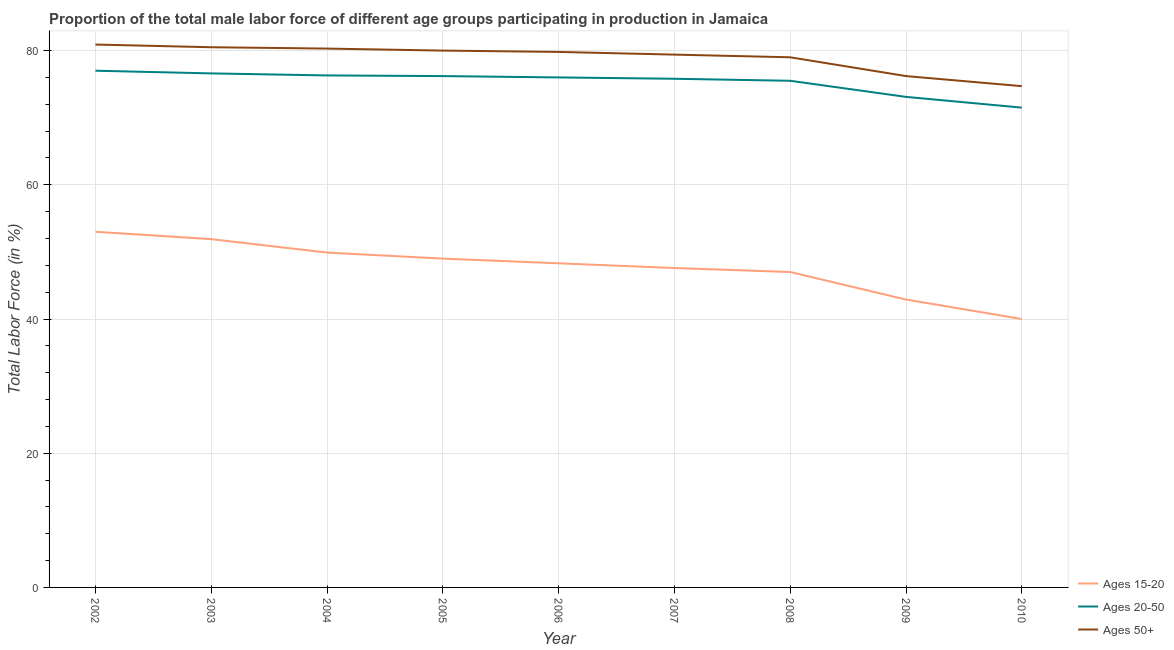How many different coloured lines are there?
Provide a short and direct response. 3. Is the number of lines equal to the number of legend labels?
Your answer should be compact. Yes. What is the percentage of male labor force within the age group 20-50 in 2010?
Your response must be concise. 71.5. Across all years, what is the maximum percentage of male labor force within the age group 20-50?
Provide a succinct answer. 77. What is the total percentage of male labor force within the age group 15-20 in the graph?
Your response must be concise. 429.6. What is the difference between the percentage of male labor force within the age group 15-20 in 2005 and that in 2008?
Offer a very short reply. 2. What is the difference between the percentage of male labor force within the age group 20-50 in 2008 and the percentage of male labor force above age 50 in 2009?
Provide a succinct answer. -0.7. What is the average percentage of male labor force above age 50 per year?
Your response must be concise. 78.98. In how many years, is the percentage of male labor force within the age group 15-20 greater than 36 %?
Provide a short and direct response. 9. What is the ratio of the percentage of male labor force within the age group 20-50 in 2008 to that in 2010?
Your answer should be compact. 1.06. Is the difference between the percentage of male labor force within the age group 15-20 in 2006 and 2007 greater than the difference between the percentage of male labor force above age 50 in 2006 and 2007?
Keep it short and to the point. Yes. What is the difference between the highest and the second highest percentage of male labor force above age 50?
Provide a succinct answer. 0.4. What is the difference between the highest and the lowest percentage of male labor force above age 50?
Offer a terse response. 6.2. Is the sum of the percentage of male labor force above age 50 in 2005 and 2009 greater than the maximum percentage of male labor force within the age group 15-20 across all years?
Offer a terse response. Yes. Is the percentage of male labor force above age 50 strictly less than the percentage of male labor force within the age group 15-20 over the years?
Offer a terse response. No. How many lines are there?
Keep it short and to the point. 3. What is the difference between two consecutive major ticks on the Y-axis?
Your answer should be compact. 20. Are the values on the major ticks of Y-axis written in scientific E-notation?
Your response must be concise. No. Does the graph contain grids?
Offer a very short reply. Yes. Where does the legend appear in the graph?
Offer a terse response. Bottom right. How many legend labels are there?
Your response must be concise. 3. What is the title of the graph?
Your response must be concise. Proportion of the total male labor force of different age groups participating in production in Jamaica. Does "Tertiary" appear as one of the legend labels in the graph?
Ensure brevity in your answer.  No. What is the label or title of the X-axis?
Give a very brief answer. Year. What is the Total Labor Force (in %) in Ages 15-20 in 2002?
Make the answer very short. 53. What is the Total Labor Force (in %) in Ages 50+ in 2002?
Your answer should be very brief. 80.9. What is the Total Labor Force (in %) in Ages 15-20 in 2003?
Provide a succinct answer. 51.9. What is the Total Labor Force (in %) of Ages 20-50 in 2003?
Your answer should be compact. 76.6. What is the Total Labor Force (in %) in Ages 50+ in 2003?
Your response must be concise. 80.5. What is the Total Labor Force (in %) of Ages 15-20 in 2004?
Your answer should be very brief. 49.9. What is the Total Labor Force (in %) of Ages 20-50 in 2004?
Offer a terse response. 76.3. What is the Total Labor Force (in %) in Ages 50+ in 2004?
Offer a terse response. 80.3. What is the Total Labor Force (in %) in Ages 15-20 in 2005?
Keep it short and to the point. 49. What is the Total Labor Force (in %) of Ages 20-50 in 2005?
Offer a terse response. 76.2. What is the Total Labor Force (in %) in Ages 50+ in 2005?
Your answer should be very brief. 80. What is the Total Labor Force (in %) in Ages 15-20 in 2006?
Ensure brevity in your answer.  48.3. What is the Total Labor Force (in %) of Ages 50+ in 2006?
Your response must be concise. 79.8. What is the Total Labor Force (in %) of Ages 15-20 in 2007?
Provide a succinct answer. 47.6. What is the Total Labor Force (in %) in Ages 20-50 in 2007?
Give a very brief answer. 75.8. What is the Total Labor Force (in %) in Ages 50+ in 2007?
Keep it short and to the point. 79.4. What is the Total Labor Force (in %) in Ages 20-50 in 2008?
Offer a terse response. 75.5. What is the Total Labor Force (in %) of Ages 50+ in 2008?
Your answer should be very brief. 79. What is the Total Labor Force (in %) in Ages 15-20 in 2009?
Offer a terse response. 42.9. What is the Total Labor Force (in %) of Ages 20-50 in 2009?
Give a very brief answer. 73.1. What is the Total Labor Force (in %) in Ages 50+ in 2009?
Offer a terse response. 76.2. What is the Total Labor Force (in %) in Ages 15-20 in 2010?
Your answer should be compact. 40. What is the Total Labor Force (in %) in Ages 20-50 in 2010?
Provide a succinct answer. 71.5. What is the Total Labor Force (in %) of Ages 50+ in 2010?
Give a very brief answer. 74.7. Across all years, what is the maximum Total Labor Force (in %) of Ages 15-20?
Offer a very short reply. 53. Across all years, what is the maximum Total Labor Force (in %) of Ages 20-50?
Your answer should be very brief. 77. Across all years, what is the maximum Total Labor Force (in %) of Ages 50+?
Ensure brevity in your answer.  80.9. Across all years, what is the minimum Total Labor Force (in %) of Ages 20-50?
Provide a succinct answer. 71.5. Across all years, what is the minimum Total Labor Force (in %) of Ages 50+?
Provide a succinct answer. 74.7. What is the total Total Labor Force (in %) of Ages 15-20 in the graph?
Your answer should be compact. 429.6. What is the total Total Labor Force (in %) in Ages 20-50 in the graph?
Your response must be concise. 678. What is the total Total Labor Force (in %) in Ages 50+ in the graph?
Keep it short and to the point. 710.8. What is the difference between the Total Labor Force (in %) in Ages 20-50 in 2002 and that in 2003?
Your response must be concise. 0.4. What is the difference between the Total Labor Force (in %) in Ages 50+ in 2002 and that in 2003?
Offer a terse response. 0.4. What is the difference between the Total Labor Force (in %) in Ages 15-20 in 2002 and that in 2004?
Give a very brief answer. 3.1. What is the difference between the Total Labor Force (in %) of Ages 50+ in 2002 and that in 2004?
Your answer should be compact. 0.6. What is the difference between the Total Labor Force (in %) of Ages 20-50 in 2002 and that in 2005?
Offer a terse response. 0.8. What is the difference between the Total Labor Force (in %) in Ages 50+ in 2002 and that in 2005?
Give a very brief answer. 0.9. What is the difference between the Total Labor Force (in %) of Ages 15-20 in 2002 and that in 2006?
Provide a short and direct response. 4.7. What is the difference between the Total Labor Force (in %) of Ages 50+ in 2002 and that in 2006?
Provide a short and direct response. 1.1. What is the difference between the Total Labor Force (in %) of Ages 15-20 in 2002 and that in 2007?
Your answer should be compact. 5.4. What is the difference between the Total Labor Force (in %) in Ages 20-50 in 2002 and that in 2007?
Give a very brief answer. 1.2. What is the difference between the Total Labor Force (in %) of Ages 50+ in 2002 and that in 2007?
Provide a short and direct response. 1.5. What is the difference between the Total Labor Force (in %) in Ages 15-20 in 2002 and that in 2008?
Provide a succinct answer. 6. What is the difference between the Total Labor Force (in %) in Ages 50+ in 2002 and that in 2008?
Provide a succinct answer. 1.9. What is the difference between the Total Labor Force (in %) of Ages 20-50 in 2002 and that in 2009?
Your answer should be compact. 3.9. What is the difference between the Total Labor Force (in %) of Ages 50+ in 2002 and that in 2009?
Make the answer very short. 4.7. What is the difference between the Total Labor Force (in %) in Ages 20-50 in 2002 and that in 2010?
Make the answer very short. 5.5. What is the difference between the Total Labor Force (in %) in Ages 20-50 in 2003 and that in 2004?
Your answer should be very brief. 0.3. What is the difference between the Total Labor Force (in %) of Ages 50+ in 2003 and that in 2004?
Provide a succinct answer. 0.2. What is the difference between the Total Labor Force (in %) of Ages 20-50 in 2003 and that in 2006?
Offer a very short reply. 0.6. What is the difference between the Total Labor Force (in %) of Ages 20-50 in 2003 and that in 2007?
Give a very brief answer. 0.8. What is the difference between the Total Labor Force (in %) of Ages 15-20 in 2003 and that in 2008?
Ensure brevity in your answer.  4.9. What is the difference between the Total Labor Force (in %) in Ages 20-50 in 2003 and that in 2008?
Ensure brevity in your answer.  1.1. What is the difference between the Total Labor Force (in %) of Ages 15-20 in 2003 and that in 2009?
Your answer should be very brief. 9. What is the difference between the Total Labor Force (in %) in Ages 20-50 in 2003 and that in 2009?
Your answer should be compact. 3.5. What is the difference between the Total Labor Force (in %) in Ages 50+ in 2003 and that in 2009?
Offer a terse response. 4.3. What is the difference between the Total Labor Force (in %) in Ages 15-20 in 2003 and that in 2010?
Your response must be concise. 11.9. What is the difference between the Total Labor Force (in %) of Ages 20-50 in 2003 and that in 2010?
Your answer should be very brief. 5.1. What is the difference between the Total Labor Force (in %) of Ages 15-20 in 2004 and that in 2005?
Give a very brief answer. 0.9. What is the difference between the Total Labor Force (in %) of Ages 20-50 in 2004 and that in 2005?
Give a very brief answer. 0.1. What is the difference between the Total Labor Force (in %) of Ages 50+ in 2004 and that in 2005?
Offer a very short reply. 0.3. What is the difference between the Total Labor Force (in %) in Ages 15-20 in 2004 and that in 2006?
Keep it short and to the point. 1.6. What is the difference between the Total Labor Force (in %) of Ages 50+ in 2004 and that in 2006?
Your response must be concise. 0.5. What is the difference between the Total Labor Force (in %) of Ages 15-20 in 2004 and that in 2007?
Give a very brief answer. 2.3. What is the difference between the Total Labor Force (in %) of Ages 50+ in 2004 and that in 2007?
Provide a succinct answer. 0.9. What is the difference between the Total Labor Force (in %) in Ages 50+ in 2004 and that in 2008?
Provide a short and direct response. 1.3. What is the difference between the Total Labor Force (in %) in Ages 20-50 in 2004 and that in 2009?
Offer a terse response. 3.2. What is the difference between the Total Labor Force (in %) in Ages 50+ in 2004 and that in 2009?
Your answer should be compact. 4.1. What is the difference between the Total Labor Force (in %) in Ages 15-20 in 2005 and that in 2006?
Offer a very short reply. 0.7. What is the difference between the Total Labor Force (in %) in Ages 20-50 in 2005 and that in 2006?
Keep it short and to the point. 0.2. What is the difference between the Total Labor Force (in %) in Ages 50+ in 2005 and that in 2006?
Your response must be concise. 0.2. What is the difference between the Total Labor Force (in %) of Ages 50+ in 2005 and that in 2007?
Give a very brief answer. 0.6. What is the difference between the Total Labor Force (in %) in Ages 15-20 in 2005 and that in 2008?
Give a very brief answer. 2. What is the difference between the Total Labor Force (in %) of Ages 20-50 in 2005 and that in 2008?
Your response must be concise. 0.7. What is the difference between the Total Labor Force (in %) of Ages 50+ in 2005 and that in 2008?
Provide a short and direct response. 1. What is the difference between the Total Labor Force (in %) of Ages 15-20 in 2005 and that in 2010?
Your response must be concise. 9. What is the difference between the Total Labor Force (in %) of Ages 15-20 in 2006 and that in 2007?
Provide a short and direct response. 0.7. What is the difference between the Total Labor Force (in %) in Ages 20-50 in 2006 and that in 2007?
Your answer should be very brief. 0.2. What is the difference between the Total Labor Force (in %) in Ages 15-20 in 2006 and that in 2008?
Your answer should be compact. 1.3. What is the difference between the Total Labor Force (in %) of Ages 20-50 in 2006 and that in 2008?
Provide a succinct answer. 0.5. What is the difference between the Total Labor Force (in %) in Ages 50+ in 2006 and that in 2008?
Provide a short and direct response. 0.8. What is the difference between the Total Labor Force (in %) of Ages 15-20 in 2006 and that in 2009?
Ensure brevity in your answer.  5.4. What is the difference between the Total Labor Force (in %) of Ages 50+ in 2006 and that in 2009?
Your answer should be very brief. 3.6. What is the difference between the Total Labor Force (in %) in Ages 20-50 in 2006 and that in 2010?
Make the answer very short. 4.5. What is the difference between the Total Labor Force (in %) in Ages 50+ in 2006 and that in 2010?
Make the answer very short. 5.1. What is the difference between the Total Labor Force (in %) of Ages 50+ in 2007 and that in 2008?
Make the answer very short. 0.4. What is the difference between the Total Labor Force (in %) in Ages 15-20 in 2007 and that in 2009?
Ensure brevity in your answer.  4.7. What is the difference between the Total Labor Force (in %) of Ages 20-50 in 2007 and that in 2009?
Provide a succinct answer. 2.7. What is the difference between the Total Labor Force (in %) in Ages 50+ in 2007 and that in 2009?
Give a very brief answer. 3.2. What is the difference between the Total Labor Force (in %) of Ages 50+ in 2007 and that in 2010?
Your answer should be compact. 4.7. What is the difference between the Total Labor Force (in %) in Ages 15-20 in 2008 and that in 2009?
Ensure brevity in your answer.  4.1. What is the difference between the Total Labor Force (in %) in Ages 20-50 in 2008 and that in 2009?
Offer a terse response. 2.4. What is the difference between the Total Labor Force (in %) in Ages 20-50 in 2008 and that in 2010?
Provide a succinct answer. 4. What is the difference between the Total Labor Force (in %) in Ages 50+ in 2008 and that in 2010?
Offer a terse response. 4.3. What is the difference between the Total Labor Force (in %) of Ages 15-20 in 2009 and that in 2010?
Provide a short and direct response. 2.9. What is the difference between the Total Labor Force (in %) in Ages 50+ in 2009 and that in 2010?
Your answer should be compact. 1.5. What is the difference between the Total Labor Force (in %) of Ages 15-20 in 2002 and the Total Labor Force (in %) of Ages 20-50 in 2003?
Give a very brief answer. -23.6. What is the difference between the Total Labor Force (in %) in Ages 15-20 in 2002 and the Total Labor Force (in %) in Ages 50+ in 2003?
Give a very brief answer. -27.5. What is the difference between the Total Labor Force (in %) in Ages 15-20 in 2002 and the Total Labor Force (in %) in Ages 20-50 in 2004?
Provide a succinct answer. -23.3. What is the difference between the Total Labor Force (in %) in Ages 15-20 in 2002 and the Total Labor Force (in %) in Ages 50+ in 2004?
Provide a succinct answer. -27.3. What is the difference between the Total Labor Force (in %) in Ages 20-50 in 2002 and the Total Labor Force (in %) in Ages 50+ in 2004?
Offer a terse response. -3.3. What is the difference between the Total Labor Force (in %) in Ages 15-20 in 2002 and the Total Labor Force (in %) in Ages 20-50 in 2005?
Give a very brief answer. -23.2. What is the difference between the Total Labor Force (in %) in Ages 20-50 in 2002 and the Total Labor Force (in %) in Ages 50+ in 2005?
Keep it short and to the point. -3. What is the difference between the Total Labor Force (in %) of Ages 15-20 in 2002 and the Total Labor Force (in %) of Ages 50+ in 2006?
Your answer should be compact. -26.8. What is the difference between the Total Labor Force (in %) of Ages 20-50 in 2002 and the Total Labor Force (in %) of Ages 50+ in 2006?
Your answer should be compact. -2.8. What is the difference between the Total Labor Force (in %) in Ages 15-20 in 2002 and the Total Labor Force (in %) in Ages 20-50 in 2007?
Your answer should be compact. -22.8. What is the difference between the Total Labor Force (in %) in Ages 15-20 in 2002 and the Total Labor Force (in %) in Ages 50+ in 2007?
Your answer should be compact. -26.4. What is the difference between the Total Labor Force (in %) of Ages 20-50 in 2002 and the Total Labor Force (in %) of Ages 50+ in 2007?
Your answer should be very brief. -2.4. What is the difference between the Total Labor Force (in %) of Ages 15-20 in 2002 and the Total Labor Force (in %) of Ages 20-50 in 2008?
Your response must be concise. -22.5. What is the difference between the Total Labor Force (in %) in Ages 20-50 in 2002 and the Total Labor Force (in %) in Ages 50+ in 2008?
Your answer should be very brief. -2. What is the difference between the Total Labor Force (in %) in Ages 15-20 in 2002 and the Total Labor Force (in %) in Ages 20-50 in 2009?
Ensure brevity in your answer.  -20.1. What is the difference between the Total Labor Force (in %) in Ages 15-20 in 2002 and the Total Labor Force (in %) in Ages 50+ in 2009?
Offer a very short reply. -23.2. What is the difference between the Total Labor Force (in %) in Ages 20-50 in 2002 and the Total Labor Force (in %) in Ages 50+ in 2009?
Your answer should be very brief. 0.8. What is the difference between the Total Labor Force (in %) of Ages 15-20 in 2002 and the Total Labor Force (in %) of Ages 20-50 in 2010?
Make the answer very short. -18.5. What is the difference between the Total Labor Force (in %) of Ages 15-20 in 2002 and the Total Labor Force (in %) of Ages 50+ in 2010?
Your answer should be compact. -21.7. What is the difference between the Total Labor Force (in %) in Ages 15-20 in 2003 and the Total Labor Force (in %) in Ages 20-50 in 2004?
Ensure brevity in your answer.  -24.4. What is the difference between the Total Labor Force (in %) of Ages 15-20 in 2003 and the Total Labor Force (in %) of Ages 50+ in 2004?
Make the answer very short. -28.4. What is the difference between the Total Labor Force (in %) of Ages 20-50 in 2003 and the Total Labor Force (in %) of Ages 50+ in 2004?
Your response must be concise. -3.7. What is the difference between the Total Labor Force (in %) of Ages 15-20 in 2003 and the Total Labor Force (in %) of Ages 20-50 in 2005?
Your response must be concise. -24.3. What is the difference between the Total Labor Force (in %) of Ages 15-20 in 2003 and the Total Labor Force (in %) of Ages 50+ in 2005?
Ensure brevity in your answer.  -28.1. What is the difference between the Total Labor Force (in %) in Ages 15-20 in 2003 and the Total Labor Force (in %) in Ages 20-50 in 2006?
Your response must be concise. -24.1. What is the difference between the Total Labor Force (in %) in Ages 15-20 in 2003 and the Total Labor Force (in %) in Ages 50+ in 2006?
Your answer should be very brief. -27.9. What is the difference between the Total Labor Force (in %) in Ages 20-50 in 2003 and the Total Labor Force (in %) in Ages 50+ in 2006?
Your answer should be very brief. -3.2. What is the difference between the Total Labor Force (in %) in Ages 15-20 in 2003 and the Total Labor Force (in %) in Ages 20-50 in 2007?
Your response must be concise. -23.9. What is the difference between the Total Labor Force (in %) in Ages 15-20 in 2003 and the Total Labor Force (in %) in Ages 50+ in 2007?
Your response must be concise. -27.5. What is the difference between the Total Labor Force (in %) in Ages 15-20 in 2003 and the Total Labor Force (in %) in Ages 20-50 in 2008?
Your answer should be compact. -23.6. What is the difference between the Total Labor Force (in %) in Ages 15-20 in 2003 and the Total Labor Force (in %) in Ages 50+ in 2008?
Your response must be concise. -27.1. What is the difference between the Total Labor Force (in %) in Ages 20-50 in 2003 and the Total Labor Force (in %) in Ages 50+ in 2008?
Ensure brevity in your answer.  -2.4. What is the difference between the Total Labor Force (in %) of Ages 15-20 in 2003 and the Total Labor Force (in %) of Ages 20-50 in 2009?
Keep it short and to the point. -21.2. What is the difference between the Total Labor Force (in %) of Ages 15-20 in 2003 and the Total Labor Force (in %) of Ages 50+ in 2009?
Give a very brief answer. -24.3. What is the difference between the Total Labor Force (in %) of Ages 15-20 in 2003 and the Total Labor Force (in %) of Ages 20-50 in 2010?
Your answer should be compact. -19.6. What is the difference between the Total Labor Force (in %) of Ages 15-20 in 2003 and the Total Labor Force (in %) of Ages 50+ in 2010?
Keep it short and to the point. -22.8. What is the difference between the Total Labor Force (in %) in Ages 20-50 in 2003 and the Total Labor Force (in %) in Ages 50+ in 2010?
Your response must be concise. 1.9. What is the difference between the Total Labor Force (in %) of Ages 15-20 in 2004 and the Total Labor Force (in %) of Ages 20-50 in 2005?
Provide a succinct answer. -26.3. What is the difference between the Total Labor Force (in %) in Ages 15-20 in 2004 and the Total Labor Force (in %) in Ages 50+ in 2005?
Provide a succinct answer. -30.1. What is the difference between the Total Labor Force (in %) in Ages 20-50 in 2004 and the Total Labor Force (in %) in Ages 50+ in 2005?
Ensure brevity in your answer.  -3.7. What is the difference between the Total Labor Force (in %) of Ages 15-20 in 2004 and the Total Labor Force (in %) of Ages 20-50 in 2006?
Offer a very short reply. -26.1. What is the difference between the Total Labor Force (in %) in Ages 15-20 in 2004 and the Total Labor Force (in %) in Ages 50+ in 2006?
Ensure brevity in your answer.  -29.9. What is the difference between the Total Labor Force (in %) in Ages 15-20 in 2004 and the Total Labor Force (in %) in Ages 20-50 in 2007?
Your answer should be very brief. -25.9. What is the difference between the Total Labor Force (in %) of Ages 15-20 in 2004 and the Total Labor Force (in %) of Ages 50+ in 2007?
Offer a terse response. -29.5. What is the difference between the Total Labor Force (in %) of Ages 20-50 in 2004 and the Total Labor Force (in %) of Ages 50+ in 2007?
Ensure brevity in your answer.  -3.1. What is the difference between the Total Labor Force (in %) of Ages 15-20 in 2004 and the Total Labor Force (in %) of Ages 20-50 in 2008?
Ensure brevity in your answer.  -25.6. What is the difference between the Total Labor Force (in %) of Ages 15-20 in 2004 and the Total Labor Force (in %) of Ages 50+ in 2008?
Provide a succinct answer. -29.1. What is the difference between the Total Labor Force (in %) in Ages 15-20 in 2004 and the Total Labor Force (in %) in Ages 20-50 in 2009?
Ensure brevity in your answer.  -23.2. What is the difference between the Total Labor Force (in %) of Ages 15-20 in 2004 and the Total Labor Force (in %) of Ages 50+ in 2009?
Give a very brief answer. -26.3. What is the difference between the Total Labor Force (in %) in Ages 20-50 in 2004 and the Total Labor Force (in %) in Ages 50+ in 2009?
Ensure brevity in your answer.  0.1. What is the difference between the Total Labor Force (in %) in Ages 15-20 in 2004 and the Total Labor Force (in %) in Ages 20-50 in 2010?
Offer a very short reply. -21.6. What is the difference between the Total Labor Force (in %) in Ages 15-20 in 2004 and the Total Labor Force (in %) in Ages 50+ in 2010?
Make the answer very short. -24.8. What is the difference between the Total Labor Force (in %) in Ages 20-50 in 2004 and the Total Labor Force (in %) in Ages 50+ in 2010?
Ensure brevity in your answer.  1.6. What is the difference between the Total Labor Force (in %) of Ages 15-20 in 2005 and the Total Labor Force (in %) of Ages 20-50 in 2006?
Give a very brief answer. -27. What is the difference between the Total Labor Force (in %) in Ages 15-20 in 2005 and the Total Labor Force (in %) in Ages 50+ in 2006?
Your answer should be compact. -30.8. What is the difference between the Total Labor Force (in %) in Ages 20-50 in 2005 and the Total Labor Force (in %) in Ages 50+ in 2006?
Ensure brevity in your answer.  -3.6. What is the difference between the Total Labor Force (in %) of Ages 15-20 in 2005 and the Total Labor Force (in %) of Ages 20-50 in 2007?
Offer a terse response. -26.8. What is the difference between the Total Labor Force (in %) of Ages 15-20 in 2005 and the Total Labor Force (in %) of Ages 50+ in 2007?
Your answer should be compact. -30.4. What is the difference between the Total Labor Force (in %) in Ages 20-50 in 2005 and the Total Labor Force (in %) in Ages 50+ in 2007?
Your answer should be compact. -3.2. What is the difference between the Total Labor Force (in %) of Ages 15-20 in 2005 and the Total Labor Force (in %) of Ages 20-50 in 2008?
Make the answer very short. -26.5. What is the difference between the Total Labor Force (in %) of Ages 15-20 in 2005 and the Total Labor Force (in %) of Ages 50+ in 2008?
Your response must be concise. -30. What is the difference between the Total Labor Force (in %) in Ages 20-50 in 2005 and the Total Labor Force (in %) in Ages 50+ in 2008?
Your response must be concise. -2.8. What is the difference between the Total Labor Force (in %) in Ages 15-20 in 2005 and the Total Labor Force (in %) in Ages 20-50 in 2009?
Make the answer very short. -24.1. What is the difference between the Total Labor Force (in %) in Ages 15-20 in 2005 and the Total Labor Force (in %) in Ages 50+ in 2009?
Provide a succinct answer. -27.2. What is the difference between the Total Labor Force (in %) in Ages 20-50 in 2005 and the Total Labor Force (in %) in Ages 50+ in 2009?
Give a very brief answer. 0. What is the difference between the Total Labor Force (in %) of Ages 15-20 in 2005 and the Total Labor Force (in %) of Ages 20-50 in 2010?
Make the answer very short. -22.5. What is the difference between the Total Labor Force (in %) of Ages 15-20 in 2005 and the Total Labor Force (in %) of Ages 50+ in 2010?
Provide a short and direct response. -25.7. What is the difference between the Total Labor Force (in %) in Ages 20-50 in 2005 and the Total Labor Force (in %) in Ages 50+ in 2010?
Your response must be concise. 1.5. What is the difference between the Total Labor Force (in %) of Ages 15-20 in 2006 and the Total Labor Force (in %) of Ages 20-50 in 2007?
Provide a succinct answer. -27.5. What is the difference between the Total Labor Force (in %) of Ages 15-20 in 2006 and the Total Labor Force (in %) of Ages 50+ in 2007?
Provide a succinct answer. -31.1. What is the difference between the Total Labor Force (in %) of Ages 15-20 in 2006 and the Total Labor Force (in %) of Ages 20-50 in 2008?
Ensure brevity in your answer.  -27.2. What is the difference between the Total Labor Force (in %) in Ages 15-20 in 2006 and the Total Labor Force (in %) in Ages 50+ in 2008?
Make the answer very short. -30.7. What is the difference between the Total Labor Force (in %) in Ages 20-50 in 2006 and the Total Labor Force (in %) in Ages 50+ in 2008?
Provide a succinct answer. -3. What is the difference between the Total Labor Force (in %) in Ages 15-20 in 2006 and the Total Labor Force (in %) in Ages 20-50 in 2009?
Your answer should be very brief. -24.8. What is the difference between the Total Labor Force (in %) in Ages 15-20 in 2006 and the Total Labor Force (in %) in Ages 50+ in 2009?
Offer a very short reply. -27.9. What is the difference between the Total Labor Force (in %) in Ages 15-20 in 2006 and the Total Labor Force (in %) in Ages 20-50 in 2010?
Your response must be concise. -23.2. What is the difference between the Total Labor Force (in %) of Ages 15-20 in 2006 and the Total Labor Force (in %) of Ages 50+ in 2010?
Your response must be concise. -26.4. What is the difference between the Total Labor Force (in %) of Ages 20-50 in 2006 and the Total Labor Force (in %) of Ages 50+ in 2010?
Offer a very short reply. 1.3. What is the difference between the Total Labor Force (in %) of Ages 15-20 in 2007 and the Total Labor Force (in %) of Ages 20-50 in 2008?
Your answer should be compact. -27.9. What is the difference between the Total Labor Force (in %) in Ages 15-20 in 2007 and the Total Labor Force (in %) in Ages 50+ in 2008?
Offer a terse response. -31.4. What is the difference between the Total Labor Force (in %) in Ages 20-50 in 2007 and the Total Labor Force (in %) in Ages 50+ in 2008?
Give a very brief answer. -3.2. What is the difference between the Total Labor Force (in %) in Ages 15-20 in 2007 and the Total Labor Force (in %) in Ages 20-50 in 2009?
Your answer should be compact. -25.5. What is the difference between the Total Labor Force (in %) in Ages 15-20 in 2007 and the Total Labor Force (in %) in Ages 50+ in 2009?
Offer a very short reply. -28.6. What is the difference between the Total Labor Force (in %) of Ages 20-50 in 2007 and the Total Labor Force (in %) of Ages 50+ in 2009?
Provide a succinct answer. -0.4. What is the difference between the Total Labor Force (in %) in Ages 15-20 in 2007 and the Total Labor Force (in %) in Ages 20-50 in 2010?
Offer a terse response. -23.9. What is the difference between the Total Labor Force (in %) in Ages 15-20 in 2007 and the Total Labor Force (in %) in Ages 50+ in 2010?
Provide a succinct answer. -27.1. What is the difference between the Total Labor Force (in %) in Ages 20-50 in 2007 and the Total Labor Force (in %) in Ages 50+ in 2010?
Your answer should be compact. 1.1. What is the difference between the Total Labor Force (in %) in Ages 15-20 in 2008 and the Total Labor Force (in %) in Ages 20-50 in 2009?
Keep it short and to the point. -26.1. What is the difference between the Total Labor Force (in %) in Ages 15-20 in 2008 and the Total Labor Force (in %) in Ages 50+ in 2009?
Your answer should be compact. -29.2. What is the difference between the Total Labor Force (in %) in Ages 15-20 in 2008 and the Total Labor Force (in %) in Ages 20-50 in 2010?
Give a very brief answer. -24.5. What is the difference between the Total Labor Force (in %) of Ages 15-20 in 2008 and the Total Labor Force (in %) of Ages 50+ in 2010?
Provide a short and direct response. -27.7. What is the difference between the Total Labor Force (in %) of Ages 15-20 in 2009 and the Total Labor Force (in %) of Ages 20-50 in 2010?
Your answer should be very brief. -28.6. What is the difference between the Total Labor Force (in %) in Ages 15-20 in 2009 and the Total Labor Force (in %) in Ages 50+ in 2010?
Keep it short and to the point. -31.8. What is the average Total Labor Force (in %) in Ages 15-20 per year?
Your answer should be very brief. 47.73. What is the average Total Labor Force (in %) of Ages 20-50 per year?
Your answer should be very brief. 75.33. What is the average Total Labor Force (in %) in Ages 50+ per year?
Your answer should be very brief. 78.98. In the year 2002, what is the difference between the Total Labor Force (in %) of Ages 15-20 and Total Labor Force (in %) of Ages 20-50?
Give a very brief answer. -24. In the year 2002, what is the difference between the Total Labor Force (in %) in Ages 15-20 and Total Labor Force (in %) in Ages 50+?
Your answer should be compact. -27.9. In the year 2002, what is the difference between the Total Labor Force (in %) in Ages 20-50 and Total Labor Force (in %) in Ages 50+?
Offer a terse response. -3.9. In the year 2003, what is the difference between the Total Labor Force (in %) in Ages 15-20 and Total Labor Force (in %) in Ages 20-50?
Provide a short and direct response. -24.7. In the year 2003, what is the difference between the Total Labor Force (in %) in Ages 15-20 and Total Labor Force (in %) in Ages 50+?
Keep it short and to the point. -28.6. In the year 2004, what is the difference between the Total Labor Force (in %) in Ages 15-20 and Total Labor Force (in %) in Ages 20-50?
Provide a succinct answer. -26.4. In the year 2004, what is the difference between the Total Labor Force (in %) of Ages 15-20 and Total Labor Force (in %) of Ages 50+?
Ensure brevity in your answer.  -30.4. In the year 2004, what is the difference between the Total Labor Force (in %) of Ages 20-50 and Total Labor Force (in %) of Ages 50+?
Give a very brief answer. -4. In the year 2005, what is the difference between the Total Labor Force (in %) of Ages 15-20 and Total Labor Force (in %) of Ages 20-50?
Keep it short and to the point. -27.2. In the year 2005, what is the difference between the Total Labor Force (in %) in Ages 15-20 and Total Labor Force (in %) in Ages 50+?
Ensure brevity in your answer.  -31. In the year 2005, what is the difference between the Total Labor Force (in %) of Ages 20-50 and Total Labor Force (in %) of Ages 50+?
Give a very brief answer. -3.8. In the year 2006, what is the difference between the Total Labor Force (in %) in Ages 15-20 and Total Labor Force (in %) in Ages 20-50?
Make the answer very short. -27.7. In the year 2006, what is the difference between the Total Labor Force (in %) of Ages 15-20 and Total Labor Force (in %) of Ages 50+?
Provide a short and direct response. -31.5. In the year 2007, what is the difference between the Total Labor Force (in %) of Ages 15-20 and Total Labor Force (in %) of Ages 20-50?
Your answer should be very brief. -28.2. In the year 2007, what is the difference between the Total Labor Force (in %) of Ages 15-20 and Total Labor Force (in %) of Ages 50+?
Your response must be concise. -31.8. In the year 2007, what is the difference between the Total Labor Force (in %) in Ages 20-50 and Total Labor Force (in %) in Ages 50+?
Your answer should be compact. -3.6. In the year 2008, what is the difference between the Total Labor Force (in %) in Ages 15-20 and Total Labor Force (in %) in Ages 20-50?
Keep it short and to the point. -28.5. In the year 2008, what is the difference between the Total Labor Force (in %) of Ages 15-20 and Total Labor Force (in %) of Ages 50+?
Your answer should be compact. -32. In the year 2009, what is the difference between the Total Labor Force (in %) of Ages 15-20 and Total Labor Force (in %) of Ages 20-50?
Your response must be concise. -30.2. In the year 2009, what is the difference between the Total Labor Force (in %) in Ages 15-20 and Total Labor Force (in %) in Ages 50+?
Offer a terse response. -33.3. In the year 2009, what is the difference between the Total Labor Force (in %) of Ages 20-50 and Total Labor Force (in %) of Ages 50+?
Offer a terse response. -3.1. In the year 2010, what is the difference between the Total Labor Force (in %) of Ages 15-20 and Total Labor Force (in %) of Ages 20-50?
Provide a succinct answer. -31.5. In the year 2010, what is the difference between the Total Labor Force (in %) in Ages 15-20 and Total Labor Force (in %) in Ages 50+?
Offer a very short reply. -34.7. In the year 2010, what is the difference between the Total Labor Force (in %) of Ages 20-50 and Total Labor Force (in %) of Ages 50+?
Ensure brevity in your answer.  -3.2. What is the ratio of the Total Labor Force (in %) of Ages 15-20 in 2002 to that in 2003?
Offer a terse response. 1.02. What is the ratio of the Total Labor Force (in %) of Ages 15-20 in 2002 to that in 2004?
Your answer should be very brief. 1.06. What is the ratio of the Total Labor Force (in %) in Ages 20-50 in 2002 to that in 2004?
Offer a very short reply. 1.01. What is the ratio of the Total Labor Force (in %) in Ages 50+ in 2002 to that in 2004?
Your answer should be compact. 1.01. What is the ratio of the Total Labor Force (in %) of Ages 15-20 in 2002 to that in 2005?
Make the answer very short. 1.08. What is the ratio of the Total Labor Force (in %) of Ages 20-50 in 2002 to that in 2005?
Keep it short and to the point. 1.01. What is the ratio of the Total Labor Force (in %) in Ages 50+ in 2002 to that in 2005?
Make the answer very short. 1.01. What is the ratio of the Total Labor Force (in %) of Ages 15-20 in 2002 to that in 2006?
Provide a succinct answer. 1.1. What is the ratio of the Total Labor Force (in %) of Ages 20-50 in 2002 to that in 2006?
Keep it short and to the point. 1.01. What is the ratio of the Total Labor Force (in %) in Ages 50+ in 2002 to that in 2006?
Offer a terse response. 1.01. What is the ratio of the Total Labor Force (in %) of Ages 15-20 in 2002 to that in 2007?
Make the answer very short. 1.11. What is the ratio of the Total Labor Force (in %) of Ages 20-50 in 2002 to that in 2007?
Offer a very short reply. 1.02. What is the ratio of the Total Labor Force (in %) of Ages 50+ in 2002 to that in 2007?
Provide a short and direct response. 1.02. What is the ratio of the Total Labor Force (in %) of Ages 15-20 in 2002 to that in 2008?
Ensure brevity in your answer.  1.13. What is the ratio of the Total Labor Force (in %) in Ages 20-50 in 2002 to that in 2008?
Your answer should be very brief. 1.02. What is the ratio of the Total Labor Force (in %) in Ages 50+ in 2002 to that in 2008?
Give a very brief answer. 1.02. What is the ratio of the Total Labor Force (in %) in Ages 15-20 in 2002 to that in 2009?
Provide a short and direct response. 1.24. What is the ratio of the Total Labor Force (in %) in Ages 20-50 in 2002 to that in 2009?
Your response must be concise. 1.05. What is the ratio of the Total Labor Force (in %) of Ages 50+ in 2002 to that in 2009?
Ensure brevity in your answer.  1.06. What is the ratio of the Total Labor Force (in %) of Ages 15-20 in 2002 to that in 2010?
Give a very brief answer. 1.32. What is the ratio of the Total Labor Force (in %) of Ages 20-50 in 2002 to that in 2010?
Give a very brief answer. 1.08. What is the ratio of the Total Labor Force (in %) of Ages 50+ in 2002 to that in 2010?
Make the answer very short. 1.08. What is the ratio of the Total Labor Force (in %) of Ages 15-20 in 2003 to that in 2004?
Your response must be concise. 1.04. What is the ratio of the Total Labor Force (in %) in Ages 20-50 in 2003 to that in 2004?
Your answer should be very brief. 1. What is the ratio of the Total Labor Force (in %) in Ages 50+ in 2003 to that in 2004?
Your answer should be very brief. 1. What is the ratio of the Total Labor Force (in %) of Ages 15-20 in 2003 to that in 2005?
Your answer should be very brief. 1.06. What is the ratio of the Total Labor Force (in %) of Ages 15-20 in 2003 to that in 2006?
Provide a short and direct response. 1.07. What is the ratio of the Total Labor Force (in %) in Ages 20-50 in 2003 to that in 2006?
Your answer should be very brief. 1.01. What is the ratio of the Total Labor Force (in %) of Ages 50+ in 2003 to that in 2006?
Your answer should be compact. 1.01. What is the ratio of the Total Labor Force (in %) in Ages 15-20 in 2003 to that in 2007?
Provide a short and direct response. 1.09. What is the ratio of the Total Labor Force (in %) in Ages 20-50 in 2003 to that in 2007?
Keep it short and to the point. 1.01. What is the ratio of the Total Labor Force (in %) in Ages 50+ in 2003 to that in 2007?
Make the answer very short. 1.01. What is the ratio of the Total Labor Force (in %) of Ages 15-20 in 2003 to that in 2008?
Keep it short and to the point. 1.1. What is the ratio of the Total Labor Force (in %) in Ages 20-50 in 2003 to that in 2008?
Give a very brief answer. 1.01. What is the ratio of the Total Labor Force (in %) of Ages 15-20 in 2003 to that in 2009?
Give a very brief answer. 1.21. What is the ratio of the Total Labor Force (in %) of Ages 20-50 in 2003 to that in 2009?
Offer a very short reply. 1.05. What is the ratio of the Total Labor Force (in %) of Ages 50+ in 2003 to that in 2009?
Give a very brief answer. 1.06. What is the ratio of the Total Labor Force (in %) of Ages 15-20 in 2003 to that in 2010?
Your response must be concise. 1.3. What is the ratio of the Total Labor Force (in %) in Ages 20-50 in 2003 to that in 2010?
Offer a terse response. 1.07. What is the ratio of the Total Labor Force (in %) of Ages 50+ in 2003 to that in 2010?
Make the answer very short. 1.08. What is the ratio of the Total Labor Force (in %) in Ages 15-20 in 2004 to that in 2005?
Offer a very short reply. 1.02. What is the ratio of the Total Labor Force (in %) in Ages 20-50 in 2004 to that in 2005?
Provide a short and direct response. 1. What is the ratio of the Total Labor Force (in %) of Ages 50+ in 2004 to that in 2005?
Give a very brief answer. 1. What is the ratio of the Total Labor Force (in %) in Ages 15-20 in 2004 to that in 2006?
Provide a succinct answer. 1.03. What is the ratio of the Total Labor Force (in %) in Ages 20-50 in 2004 to that in 2006?
Give a very brief answer. 1. What is the ratio of the Total Labor Force (in %) of Ages 50+ in 2004 to that in 2006?
Give a very brief answer. 1.01. What is the ratio of the Total Labor Force (in %) in Ages 15-20 in 2004 to that in 2007?
Keep it short and to the point. 1.05. What is the ratio of the Total Labor Force (in %) of Ages 20-50 in 2004 to that in 2007?
Make the answer very short. 1.01. What is the ratio of the Total Labor Force (in %) of Ages 50+ in 2004 to that in 2007?
Ensure brevity in your answer.  1.01. What is the ratio of the Total Labor Force (in %) of Ages 15-20 in 2004 to that in 2008?
Ensure brevity in your answer.  1.06. What is the ratio of the Total Labor Force (in %) of Ages 20-50 in 2004 to that in 2008?
Make the answer very short. 1.01. What is the ratio of the Total Labor Force (in %) in Ages 50+ in 2004 to that in 2008?
Give a very brief answer. 1.02. What is the ratio of the Total Labor Force (in %) of Ages 15-20 in 2004 to that in 2009?
Your answer should be very brief. 1.16. What is the ratio of the Total Labor Force (in %) of Ages 20-50 in 2004 to that in 2009?
Offer a very short reply. 1.04. What is the ratio of the Total Labor Force (in %) in Ages 50+ in 2004 to that in 2009?
Give a very brief answer. 1.05. What is the ratio of the Total Labor Force (in %) in Ages 15-20 in 2004 to that in 2010?
Provide a succinct answer. 1.25. What is the ratio of the Total Labor Force (in %) of Ages 20-50 in 2004 to that in 2010?
Your answer should be very brief. 1.07. What is the ratio of the Total Labor Force (in %) in Ages 50+ in 2004 to that in 2010?
Offer a terse response. 1.07. What is the ratio of the Total Labor Force (in %) in Ages 15-20 in 2005 to that in 2006?
Ensure brevity in your answer.  1.01. What is the ratio of the Total Labor Force (in %) in Ages 15-20 in 2005 to that in 2007?
Give a very brief answer. 1.03. What is the ratio of the Total Labor Force (in %) of Ages 20-50 in 2005 to that in 2007?
Your response must be concise. 1.01. What is the ratio of the Total Labor Force (in %) of Ages 50+ in 2005 to that in 2007?
Give a very brief answer. 1.01. What is the ratio of the Total Labor Force (in %) of Ages 15-20 in 2005 to that in 2008?
Give a very brief answer. 1.04. What is the ratio of the Total Labor Force (in %) of Ages 20-50 in 2005 to that in 2008?
Your response must be concise. 1.01. What is the ratio of the Total Labor Force (in %) of Ages 50+ in 2005 to that in 2008?
Provide a succinct answer. 1.01. What is the ratio of the Total Labor Force (in %) in Ages 15-20 in 2005 to that in 2009?
Your response must be concise. 1.14. What is the ratio of the Total Labor Force (in %) in Ages 20-50 in 2005 to that in 2009?
Offer a very short reply. 1.04. What is the ratio of the Total Labor Force (in %) of Ages 50+ in 2005 to that in 2009?
Offer a terse response. 1.05. What is the ratio of the Total Labor Force (in %) in Ages 15-20 in 2005 to that in 2010?
Your response must be concise. 1.23. What is the ratio of the Total Labor Force (in %) in Ages 20-50 in 2005 to that in 2010?
Provide a short and direct response. 1.07. What is the ratio of the Total Labor Force (in %) of Ages 50+ in 2005 to that in 2010?
Keep it short and to the point. 1.07. What is the ratio of the Total Labor Force (in %) of Ages 15-20 in 2006 to that in 2007?
Your answer should be compact. 1.01. What is the ratio of the Total Labor Force (in %) of Ages 20-50 in 2006 to that in 2007?
Your response must be concise. 1. What is the ratio of the Total Labor Force (in %) in Ages 50+ in 2006 to that in 2007?
Give a very brief answer. 1. What is the ratio of the Total Labor Force (in %) in Ages 15-20 in 2006 to that in 2008?
Your answer should be compact. 1.03. What is the ratio of the Total Labor Force (in %) in Ages 20-50 in 2006 to that in 2008?
Give a very brief answer. 1.01. What is the ratio of the Total Labor Force (in %) in Ages 15-20 in 2006 to that in 2009?
Offer a very short reply. 1.13. What is the ratio of the Total Labor Force (in %) in Ages 20-50 in 2006 to that in 2009?
Offer a terse response. 1.04. What is the ratio of the Total Labor Force (in %) of Ages 50+ in 2006 to that in 2009?
Your answer should be compact. 1.05. What is the ratio of the Total Labor Force (in %) in Ages 15-20 in 2006 to that in 2010?
Your answer should be very brief. 1.21. What is the ratio of the Total Labor Force (in %) of Ages 20-50 in 2006 to that in 2010?
Ensure brevity in your answer.  1.06. What is the ratio of the Total Labor Force (in %) of Ages 50+ in 2006 to that in 2010?
Offer a terse response. 1.07. What is the ratio of the Total Labor Force (in %) of Ages 15-20 in 2007 to that in 2008?
Provide a short and direct response. 1.01. What is the ratio of the Total Labor Force (in %) in Ages 20-50 in 2007 to that in 2008?
Your response must be concise. 1. What is the ratio of the Total Labor Force (in %) in Ages 50+ in 2007 to that in 2008?
Provide a short and direct response. 1.01. What is the ratio of the Total Labor Force (in %) in Ages 15-20 in 2007 to that in 2009?
Offer a terse response. 1.11. What is the ratio of the Total Labor Force (in %) in Ages 20-50 in 2007 to that in 2009?
Make the answer very short. 1.04. What is the ratio of the Total Labor Force (in %) of Ages 50+ in 2007 to that in 2009?
Give a very brief answer. 1.04. What is the ratio of the Total Labor Force (in %) of Ages 15-20 in 2007 to that in 2010?
Ensure brevity in your answer.  1.19. What is the ratio of the Total Labor Force (in %) in Ages 20-50 in 2007 to that in 2010?
Provide a short and direct response. 1.06. What is the ratio of the Total Labor Force (in %) in Ages 50+ in 2007 to that in 2010?
Ensure brevity in your answer.  1.06. What is the ratio of the Total Labor Force (in %) of Ages 15-20 in 2008 to that in 2009?
Your answer should be compact. 1.1. What is the ratio of the Total Labor Force (in %) of Ages 20-50 in 2008 to that in 2009?
Make the answer very short. 1.03. What is the ratio of the Total Labor Force (in %) in Ages 50+ in 2008 to that in 2009?
Your answer should be compact. 1.04. What is the ratio of the Total Labor Force (in %) in Ages 15-20 in 2008 to that in 2010?
Offer a very short reply. 1.18. What is the ratio of the Total Labor Force (in %) of Ages 20-50 in 2008 to that in 2010?
Ensure brevity in your answer.  1.06. What is the ratio of the Total Labor Force (in %) in Ages 50+ in 2008 to that in 2010?
Provide a succinct answer. 1.06. What is the ratio of the Total Labor Force (in %) in Ages 15-20 in 2009 to that in 2010?
Keep it short and to the point. 1.07. What is the ratio of the Total Labor Force (in %) in Ages 20-50 in 2009 to that in 2010?
Give a very brief answer. 1.02. What is the ratio of the Total Labor Force (in %) of Ages 50+ in 2009 to that in 2010?
Your response must be concise. 1.02. What is the difference between the highest and the second highest Total Labor Force (in %) in Ages 20-50?
Provide a succinct answer. 0.4. What is the difference between the highest and the lowest Total Labor Force (in %) of Ages 20-50?
Your answer should be very brief. 5.5. What is the difference between the highest and the lowest Total Labor Force (in %) of Ages 50+?
Your answer should be very brief. 6.2. 